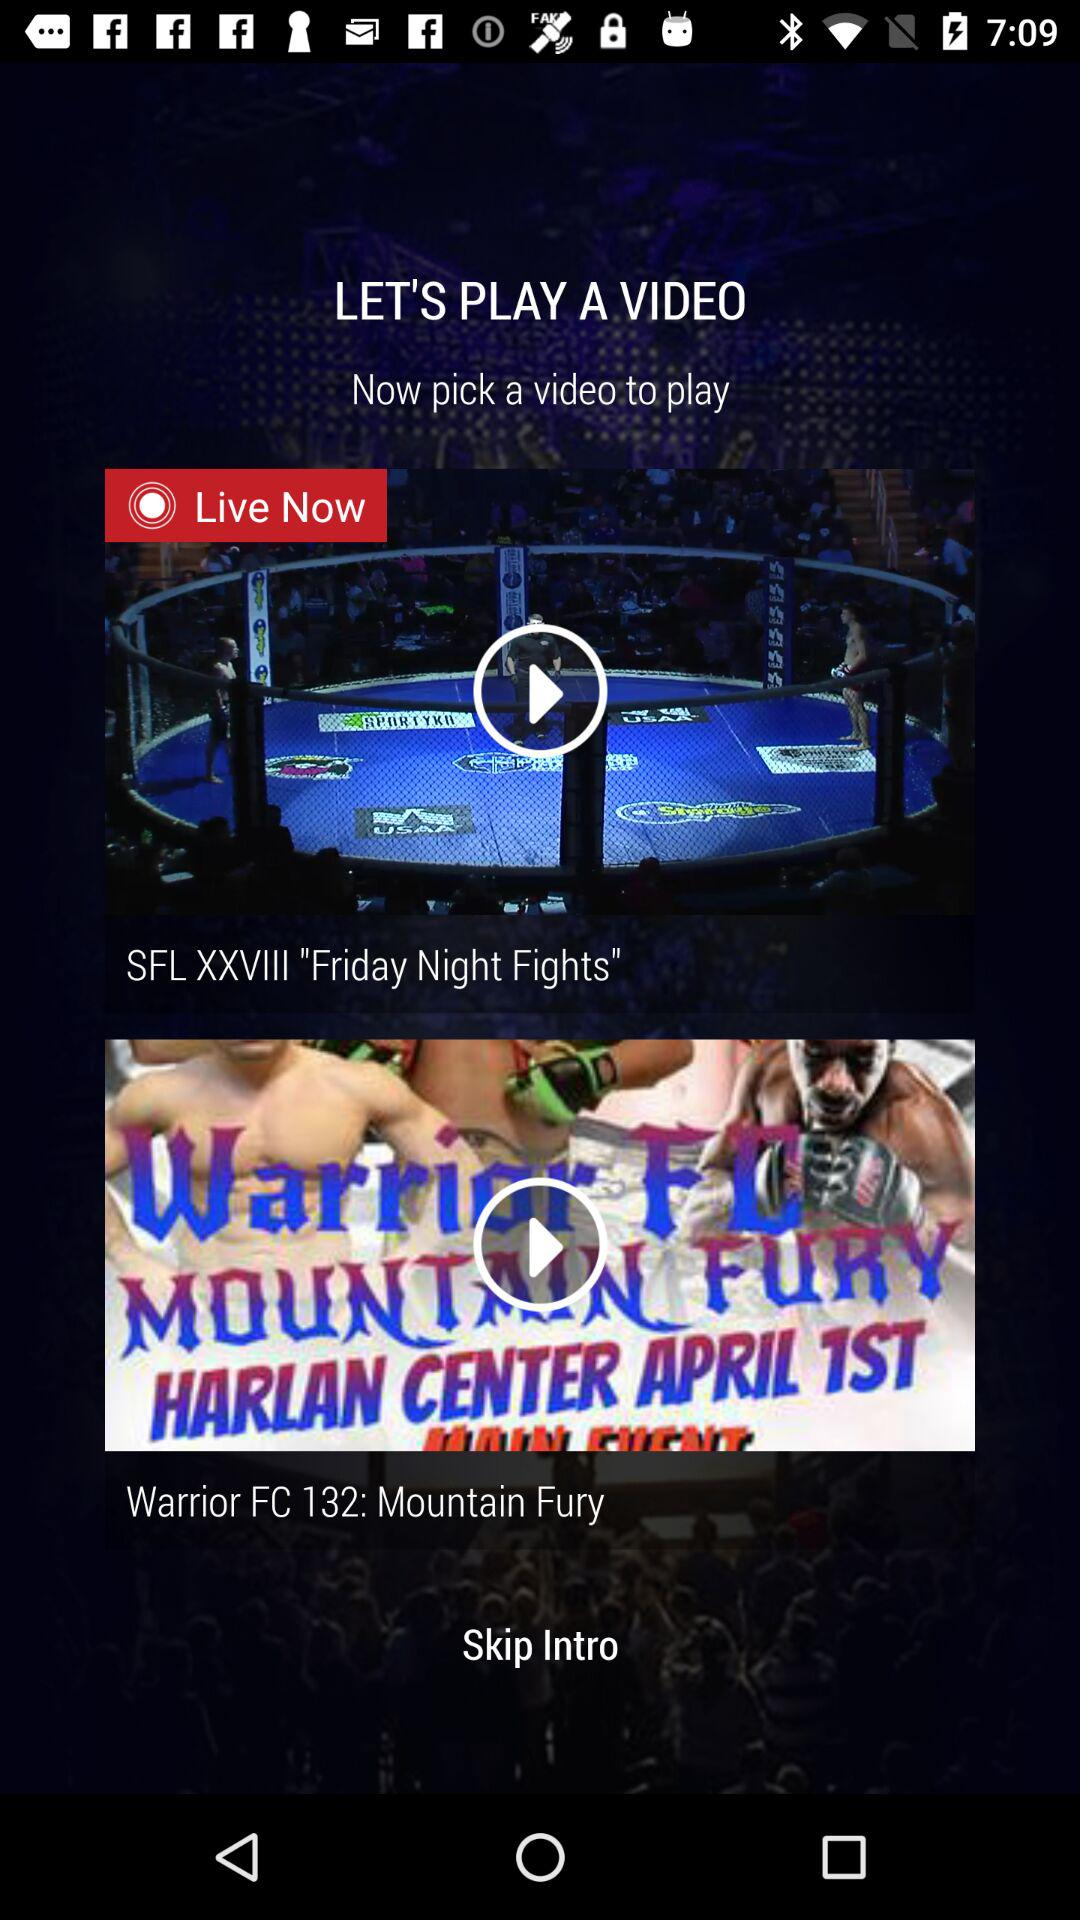How many video items are there?
Answer the question using a single word or phrase. 2 